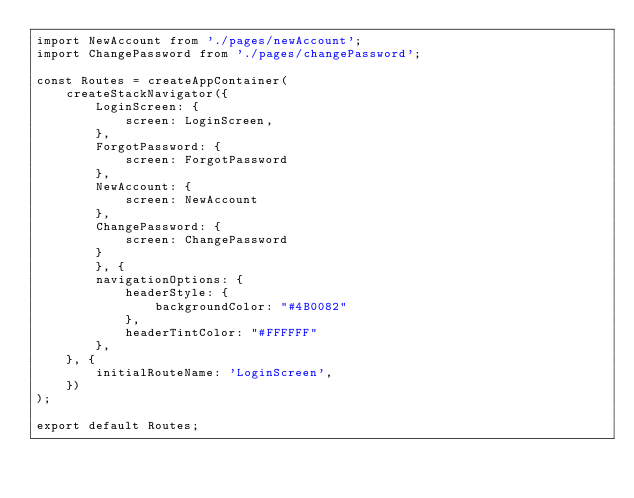<code> <loc_0><loc_0><loc_500><loc_500><_JavaScript_>import NewAccount from './pages/newAccount';
import ChangePassword from './pages/changePassword';

const Routes = createAppContainer(
    createStackNavigator({
        LoginScreen: {
            screen: LoginScreen,
        },
        ForgotPassword: {
            screen: ForgotPassword
        },
        NewAccount: {
            screen: NewAccount
        },
        ChangePassword: {
            screen: ChangePassword
        }
        }, {
        navigationOptions: {
            headerStyle: {
                backgroundColor: "#4B0082"
            },
            headerTintColor: "#FFFFFF"
        }, 
    }, {
        initialRouteName: 'LoginScreen',
    })
);

export default Routes;</code> 